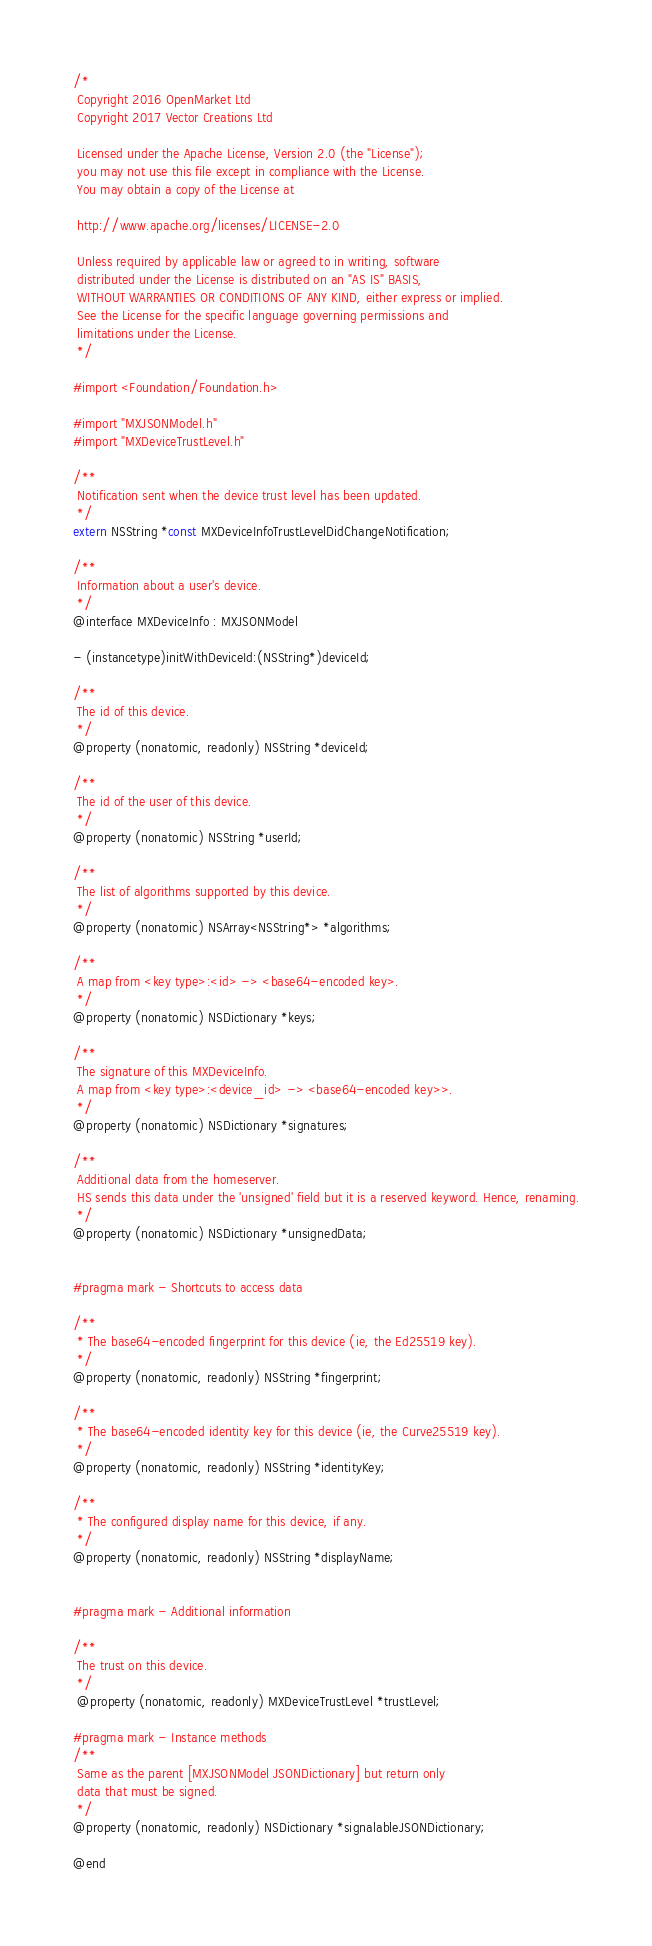Convert code to text. <code><loc_0><loc_0><loc_500><loc_500><_C_>/*
 Copyright 2016 OpenMarket Ltd
 Copyright 2017 Vector Creations Ltd

 Licensed under the Apache License, Version 2.0 (the "License");
 you may not use this file except in compliance with the License.
 You may obtain a copy of the License at

 http://www.apache.org/licenses/LICENSE-2.0

 Unless required by applicable law or agreed to in writing, software
 distributed under the License is distributed on an "AS IS" BASIS,
 WITHOUT WARRANTIES OR CONDITIONS OF ANY KIND, either express or implied.
 See the License for the specific language governing permissions and
 limitations under the License.
 */

#import <Foundation/Foundation.h>

#import "MXJSONModel.h"
#import "MXDeviceTrustLevel.h"

/**
 Notification sent when the device trust level has been updated.
 */
extern NSString *const MXDeviceInfoTrustLevelDidChangeNotification;

/**
 Information about a user's device.
 */
@interface MXDeviceInfo : MXJSONModel

- (instancetype)initWithDeviceId:(NSString*)deviceId;

/**
 The id of this device.
 */
@property (nonatomic, readonly) NSString *deviceId;

/**
 The id of the user of this device.
 */
@property (nonatomic) NSString *userId;

/**
 The list of algorithms supported by this device.
 */
@property (nonatomic) NSArray<NSString*> *algorithms;

/**
 A map from <key type>:<id> -> <base64-encoded key>.
 */
@property (nonatomic) NSDictionary *keys;

/**
 The signature of this MXDeviceInfo.
 A map from <key type>:<device_id> -> <base64-encoded key>>.
 */
@property (nonatomic) NSDictionary *signatures;

/**
 Additional data from the homeserver.
 HS sends this data under the 'unsigned' field but it is a reserved keyword. Hence, renaming.
 */
@property (nonatomic) NSDictionary *unsignedData;


#pragma mark - Shortcuts to access data

/**
 * The base64-encoded fingerprint for this device (ie, the Ed25519 key).
 */
@property (nonatomic, readonly) NSString *fingerprint;

/**
 * The base64-encoded identity key for this device (ie, the Curve25519 key).
 */
@property (nonatomic, readonly) NSString *identityKey;

/**
 * The configured display name for this device, if any.
 */
@property (nonatomic, readonly) NSString *displayName;


#pragma mark - Additional information

/**
 The trust on this device.
 */
 @property (nonatomic, readonly) MXDeviceTrustLevel *trustLevel;

#pragma mark - Instance methods
/**
 Same as the parent [MXJSONModel JSONDictionary] but return only
 data that must be signed.
 */
@property (nonatomic, readonly) NSDictionary *signalableJSONDictionary;

@end
</code> 